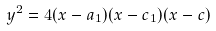<formula> <loc_0><loc_0><loc_500><loc_500>y ^ { 2 } = 4 ( x - a _ { 1 } ) ( x - c _ { 1 } ) ( x - c )</formula> 